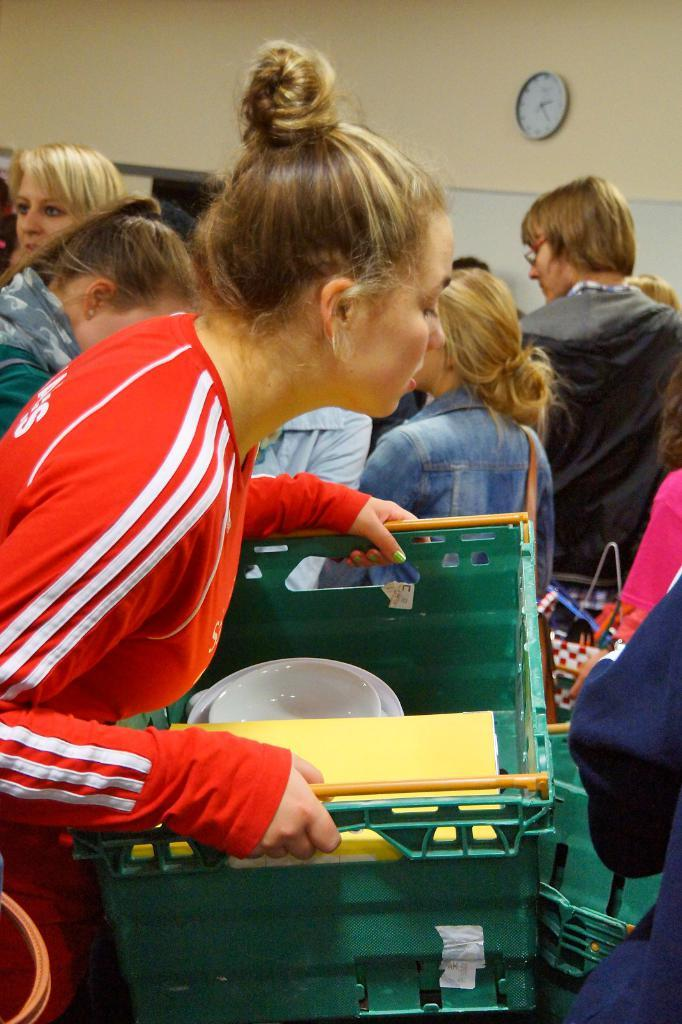What are the people in the image doing? The people are standing in the image and holding a tub. What is inside the tub? There are bowls and paper in the tub. Can you describe any objects on the wall in the image? There is a clock and a board attached to the wall in the image. What type of knee can be seen on the board in the image? There is no knee present on the board in the image. Can you hear the ear in the image? There is no ear present in the image, so it cannot be heard. 